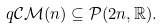<formula> <loc_0><loc_0><loc_500><loc_500>q \mathcal { C M } ( n ) \subseteq \mathcal { P } ( 2 n , \mathbb { R } ) .</formula> 